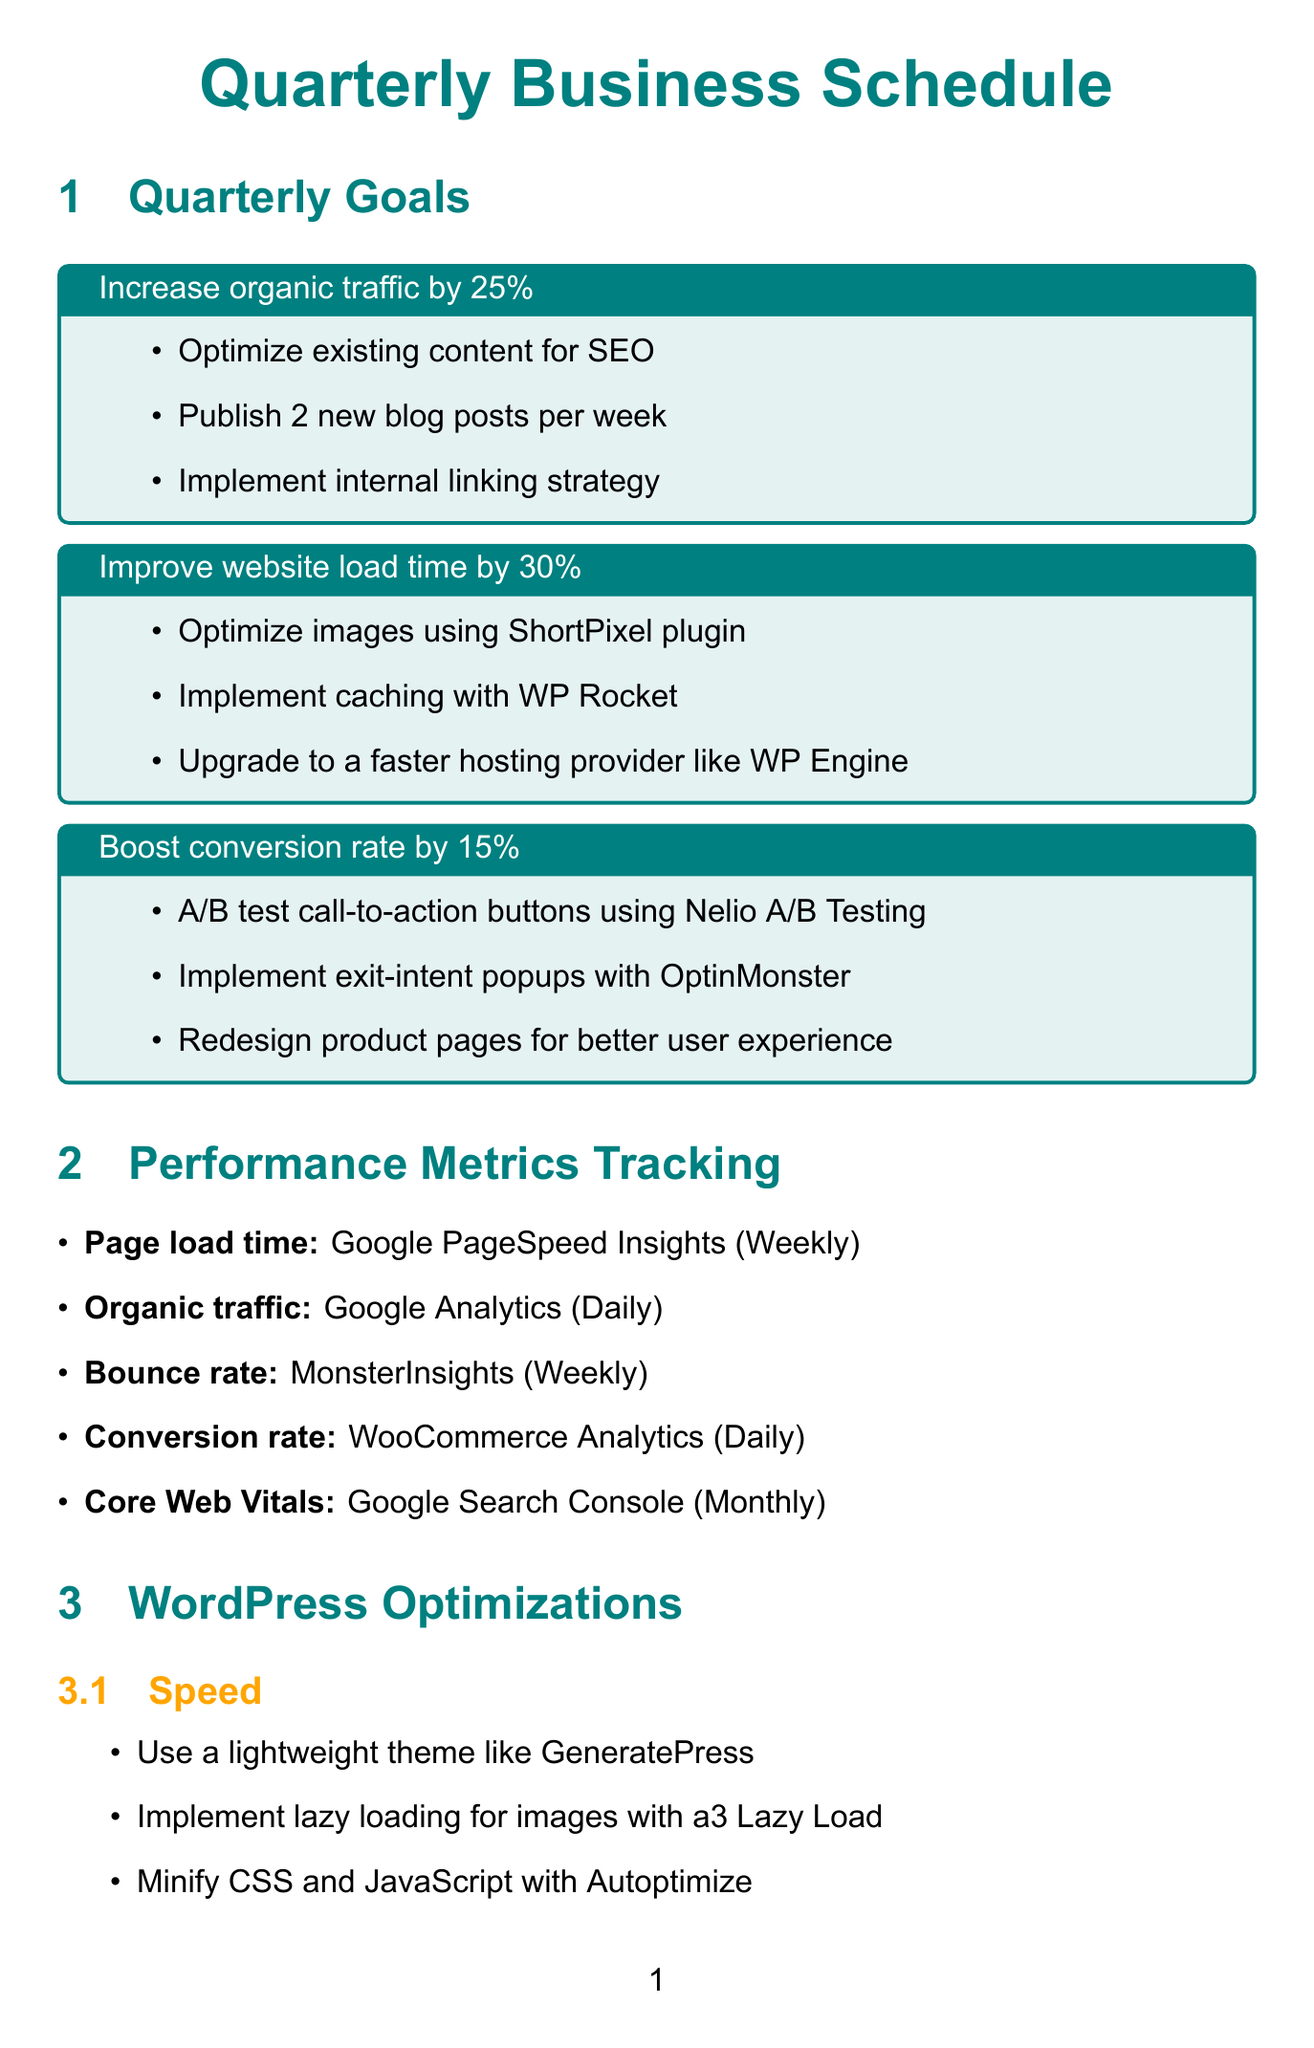what is the first quarterly goal listed? The first quarterly goal listed in the document is to increase organic traffic.
Answer: Increase organic traffic by 25% how many new blog posts are to be published per week? The document specifies publishing two new blog posts each week.
Answer: 2 which tool is used to track organic traffic? The tool mentioned in the document for tracking organic traffic is Google Analytics.
Answer: Google Analytics what is the target percentage for improving the conversion rate? The document states the target for boosting the conversion rate is 15 percent.
Answer: 15% how often is the page load time tracked? The page load time is tracked weekly, as indicated in the document.
Answer: Weekly what is one action to improve website speed? One action listed for improving website speed is to implement lazy loading for images.
Answer: Implement lazy loading for images which plugin is suggested for implementing exit-intent popups? The document mentions using OptinMonster for implementing exit-intent popups.
Answer: OptinMonster what category does the technique of using a lightweight theme fall under? The technique of using a lightweight theme like GeneratePress falls under the category of speed.
Answer: Speed how many areas of business improvements are listed? There are three areas of business improvements listed in the document.
Answer: 3 what action is recommended for customer support improvement? One recommended action for customer support improvement is to implement live chat.
Answer: Implement live chat 